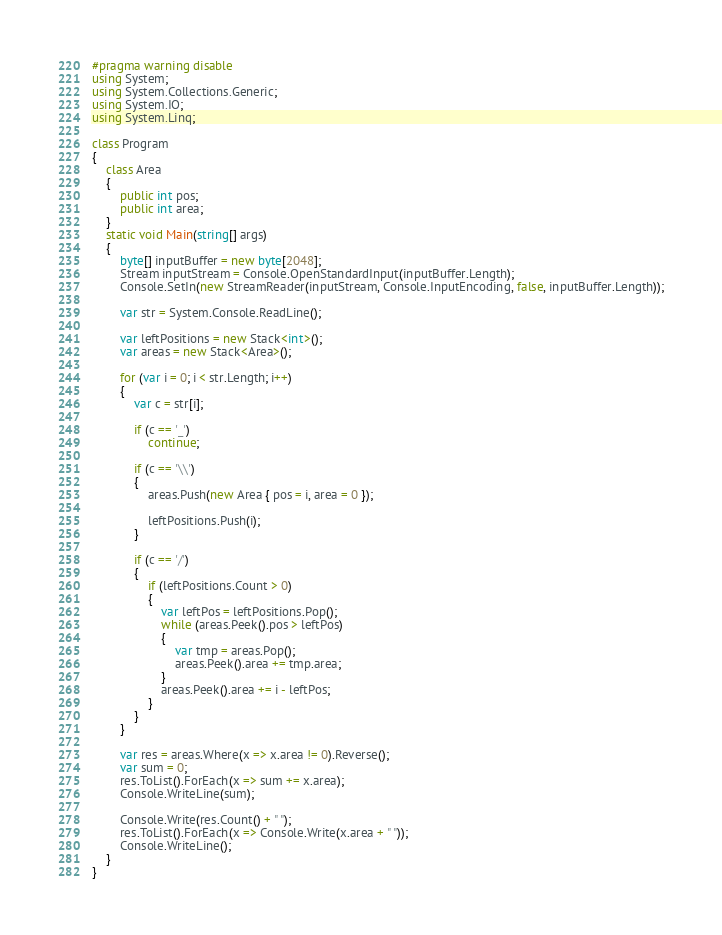<code> <loc_0><loc_0><loc_500><loc_500><_C#_>#pragma warning disable
using System;
using System.Collections.Generic;
using System.IO;
using System.Linq;

class Program
{
    class Area
    {
        public int pos;
        public int area;
    }
    static void Main(string[] args)
    {
        byte[] inputBuffer = new byte[2048];
        Stream inputStream = Console.OpenStandardInput(inputBuffer.Length);
        Console.SetIn(new StreamReader(inputStream, Console.InputEncoding, false, inputBuffer.Length));

        var str = System.Console.ReadLine();

        var leftPositions = new Stack<int>();
        var areas = new Stack<Area>();

        for (var i = 0; i < str.Length; i++)
        {
            var c = str[i];

            if (c == '_')
                continue;

            if (c == '\\')
            {
                areas.Push(new Area { pos = i, area = 0 });

                leftPositions.Push(i);
            }

            if (c == '/')
            {
                if (leftPositions.Count > 0)
                {
                    var leftPos = leftPositions.Pop();
                    while (areas.Peek().pos > leftPos)
                    {
                        var tmp = areas.Pop();
                        areas.Peek().area += tmp.area;
                    }
                    areas.Peek().area += i - leftPos;
                }
            }
        }

        var res = areas.Where(x => x.area != 0).Reverse();
        var sum = 0;
        res.ToList().ForEach(x => sum += x.area);
        Console.WriteLine(sum);

        Console.Write(res.Count() + " ");
        res.ToList().ForEach(x => Console.Write(x.area + " "));
        Console.WriteLine();
    }
}</code> 